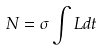<formula> <loc_0><loc_0><loc_500><loc_500>N = \sigma \int L d t</formula> 